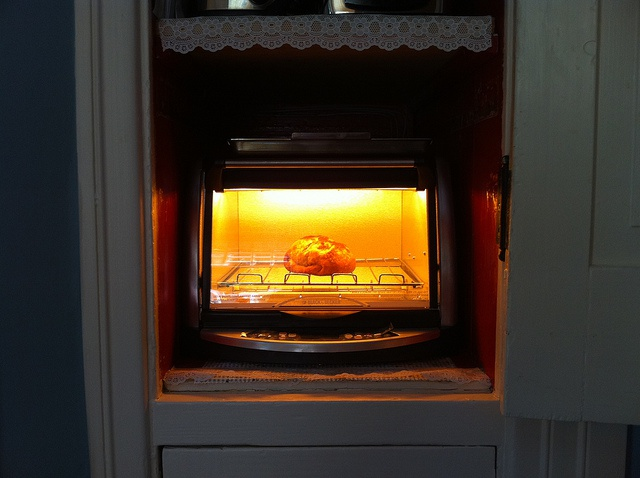Describe the objects in this image and their specific colors. I can see a oven in black, maroon, orange, and gold tones in this image. 